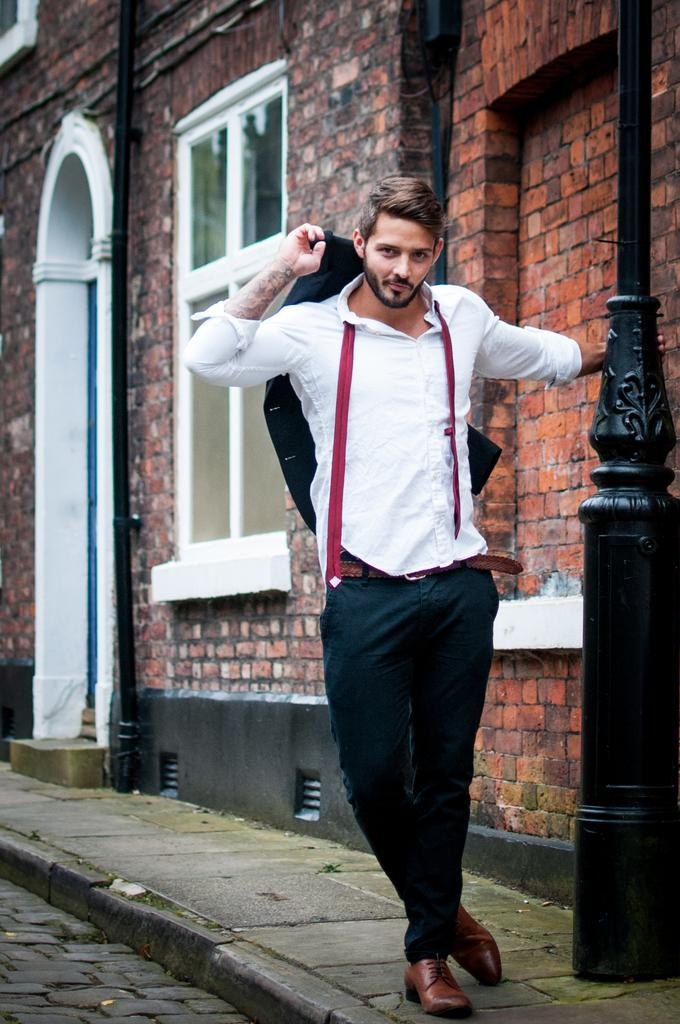What is the main subject of the image? There is a person standing in the image. What is the person doing in the image? The person is posing for the picture. What object is the person holding in the image? The person is holding a pole. What can be seen in the background of the image? There is a building visible in the background of the image. What type of smoke can be seen coming from the person's sock in the image? There is no smoke or sock present in the image; the person is holding a pole and standing in front of a building. 